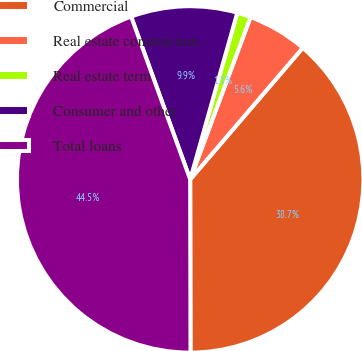Convert chart. <chart><loc_0><loc_0><loc_500><loc_500><pie_chart><fcel>Commercial<fcel>Real estate construction<fcel>Real estate term<fcel>Consumer and other<fcel>Total loans<nl><fcel>38.7%<fcel>5.6%<fcel>1.28%<fcel>9.92%<fcel>44.49%<nl></chart> 